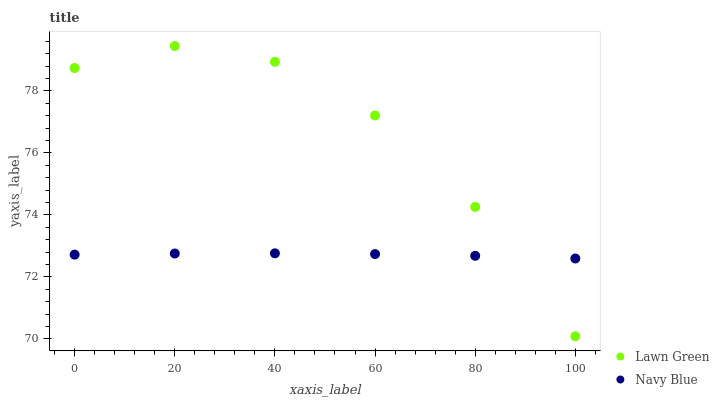Does Navy Blue have the minimum area under the curve?
Answer yes or no. Yes. Does Lawn Green have the maximum area under the curve?
Answer yes or no. Yes. Does Navy Blue have the maximum area under the curve?
Answer yes or no. No. Is Navy Blue the smoothest?
Answer yes or no. Yes. Is Lawn Green the roughest?
Answer yes or no. Yes. Is Navy Blue the roughest?
Answer yes or no. No. Does Lawn Green have the lowest value?
Answer yes or no. Yes. Does Navy Blue have the lowest value?
Answer yes or no. No. Does Lawn Green have the highest value?
Answer yes or no. Yes. Does Navy Blue have the highest value?
Answer yes or no. No. Does Navy Blue intersect Lawn Green?
Answer yes or no. Yes. Is Navy Blue less than Lawn Green?
Answer yes or no. No. Is Navy Blue greater than Lawn Green?
Answer yes or no. No. 